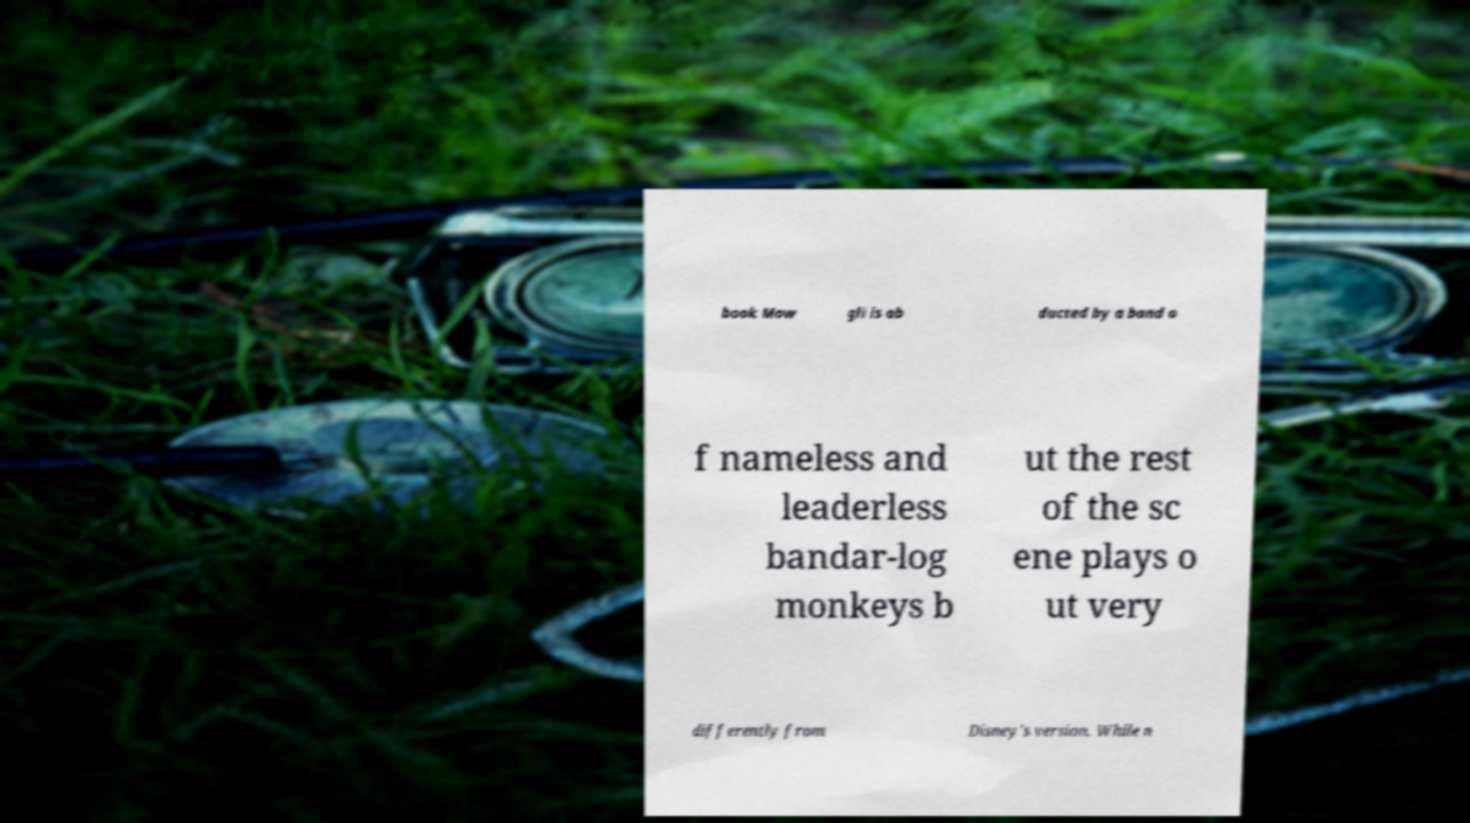Please identify and transcribe the text found in this image. book Mow gli is ab ducted by a band o f nameless and leaderless bandar-log monkeys b ut the rest of the sc ene plays o ut very differently from Disney's version. While n 